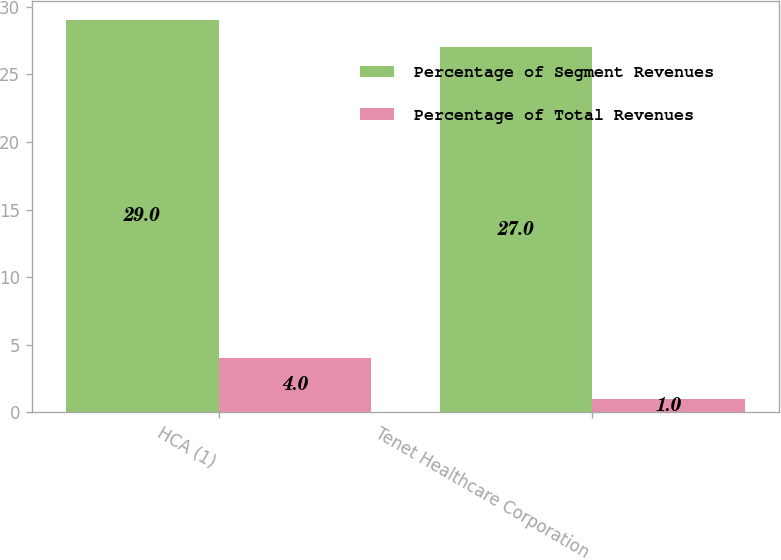Convert chart to OTSL. <chart><loc_0><loc_0><loc_500><loc_500><stacked_bar_chart><ecel><fcel>HCA (1)<fcel>Tenet Healthcare Corporation<nl><fcel>Percentage of Segment Revenues<fcel>29<fcel>27<nl><fcel>Percentage of Total Revenues<fcel>4<fcel>1<nl></chart> 